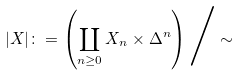Convert formula to latex. <formula><loc_0><loc_0><loc_500><loc_500>| X | \colon = \left ( \coprod _ { n \geq 0 } X _ { n } \times \Delta ^ { n } \right ) \Big / \sim</formula> 